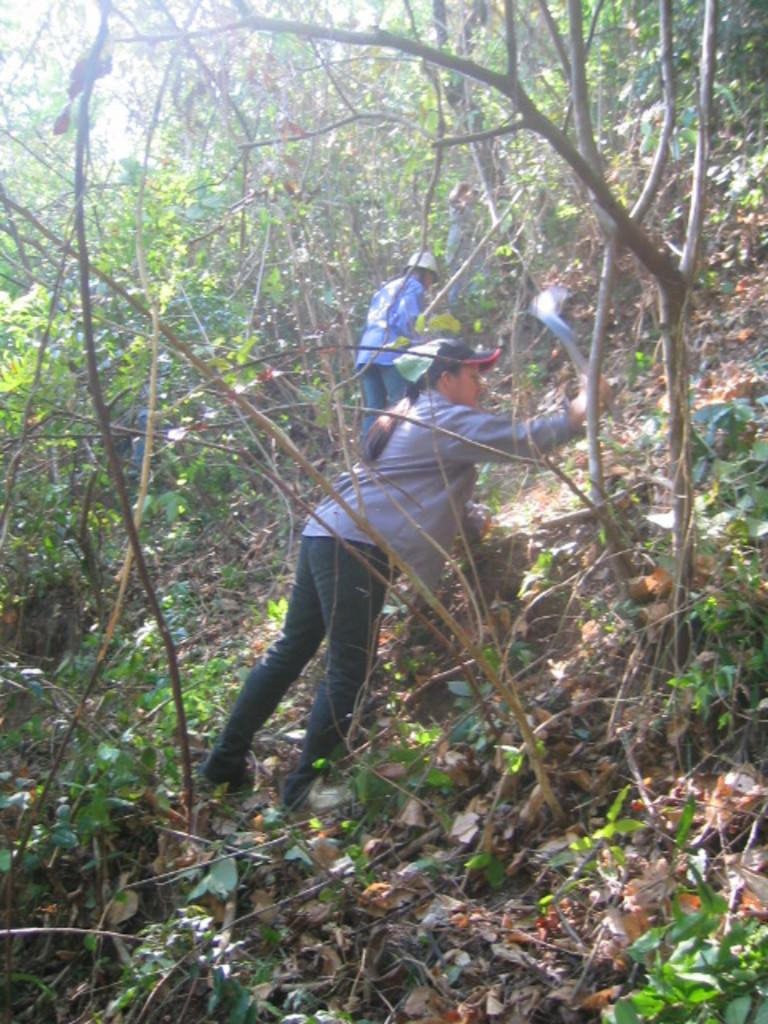Who is the main subject in the image? There is a woman in the image. What is the woman doing in the image? The woman is cutting trees in the image. What type of vegetation is present in the image? There are trees and dried leaves in the image. What type of sheet is being used to cover the trees in the image? There is no sheet present in the image; the woman is cutting trees, not covering them. 